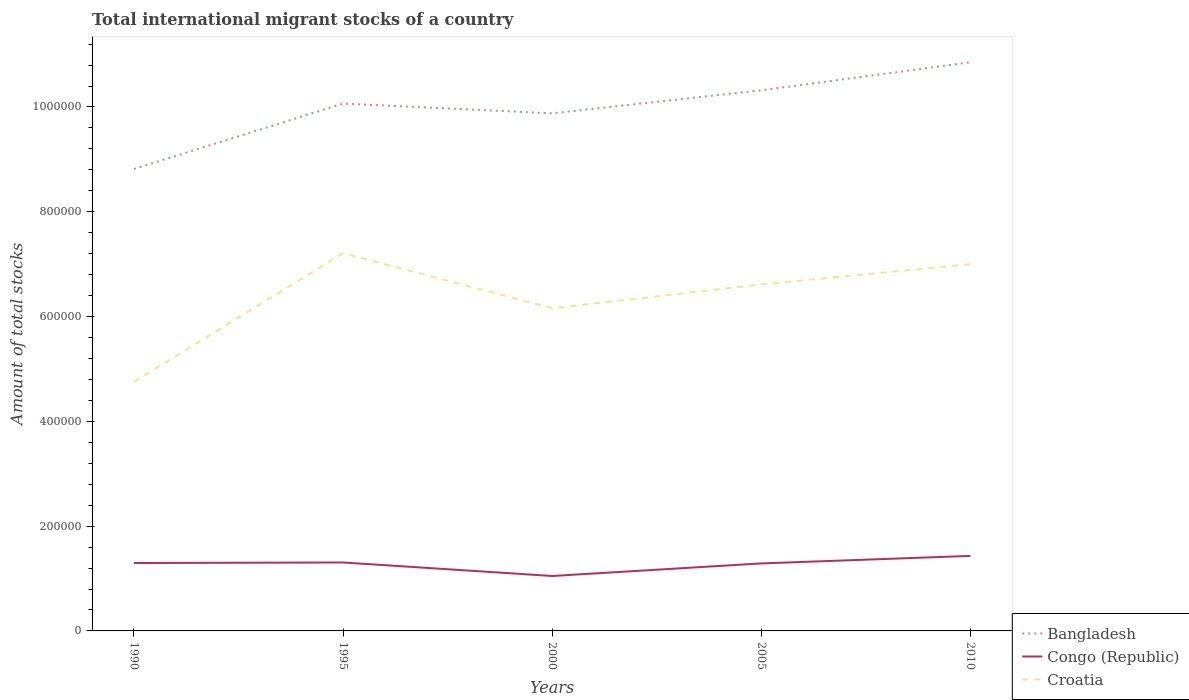How many different coloured lines are there?
Keep it short and to the point. 3. Does the line corresponding to Bangladesh intersect with the line corresponding to Croatia?
Provide a succinct answer. No. Across all years, what is the maximum amount of total stocks in in Congo (Republic)?
Give a very brief answer. 1.05e+05. What is the total amount of total stocks in in Congo (Republic) in the graph?
Your response must be concise. 2.58e+04. What is the difference between the highest and the second highest amount of total stocks in in Bangladesh?
Your answer should be very brief. 2.04e+05. What is the difference between the highest and the lowest amount of total stocks in in Congo (Republic)?
Keep it short and to the point. 4. How many years are there in the graph?
Ensure brevity in your answer.  5. Are the values on the major ticks of Y-axis written in scientific E-notation?
Your answer should be very brief. No. Does the graph contain grids?
Provide a short and direct response. No. How many legend labels are there?
Offer a terse response. 3. How are the legend labels stacked?
Provide a succinct answer. Vertical. What is the title of the graph?
Offer a terse response. Total international migrant stocks of a country. What is the label or title of the Y-axis?
Your answer should be very brief. Amount of total stocks. What is the Amount of total stocks of Bangladesh in 1990?
Give a very brief answer. 8.82e+05. What is the Amount of total stocks of Congo (Republic) in 1990?
Give a very brief answer. 1.30e+05. What is the Amount of total stocks in Croatia in 1990?
Ensure brevity in your answer.  4.75e+05. What is the Amount of total stocks in Bangladesh in 1995?
Offer a very short reply. 1.01e+06. What is the Amount of total stocks in Congo (Republic) in 1995?
Your answer should be very brief. 1.31e+05. What is the Amount of total stocks in Croatia in 1995?
Your response must be concise. 7.21e+05. What is the Amount of total stocks in Bangladesh in 2000?
Ensure brevity in your answer.  9.88e+05. What is the Amount of total stocks in Congo (Republic) in 2000?
Your response must be concise. 1.05e+05. What is the Amount of total stocks of Croatia in 2000?
Keep it short and to the point. 6.16e+05. What is the Amount of total stocks of Bangladesh in 2005?
Ensure brevity in your answer.  1.03e+06. What is the Amount of total stocks in Congo (Republic) in 2005?
Offer a terse response. 1.29e+05. What is the Amount of total stocks of Croatia in 2005?
Provide a short and direct response. 6.61e+05. What is the Amount of total stocks of Bangladesh in 2010?
Offer a very short reply. 1.09e+06. What is the Amount of total stocks in Congo (Republic) in 2010?
Make the answer very short. 1.43e+05. What is the Amount of total stocks of Croatia in 2010?
Offer a terse response. 7.00e+05. Across all years, what is the maximum Amount of total stocks of Bangladesh?
Provide a short and direct response. 1.09e+06. Across all years, what is the maximum Amount of total stocks of Congo (Republic)?
Your response must be concise. 1.43e+05. Across all years, what is the maximum Amount of total stocks in Croatia?
Offer a terse response. 7.21e+05. Across all years, what is the minimum Amount of total stocks of Bangladesh?
Make the answer very short. 8.82e+05. Across all years, what is the minimum Amount of total stocks in Congo (Republic)?
Your answer should be compact. 1.05e+05. Across all years, what is the minimum Amount of total stocks of Croatia?
Offer a terse response. 4.75e+05. What is the total Amount of total stocks in Bangladesh in the graph?
Give a very brief answer. 4.99e+06. What is the total Amount of total stocks in Congo (Republic) in the graph?
Offer a terse response. 6.37e+05. What is the total Amount of total stocks of Croatia in the graph?
Give a very brief answer. 3.17e+06. What is the difference between the Amount of total stocks in Bangladesh in 1990 and that in 1995?
Give a very brief answer. -1.25e+05. What is the difference between the Amount of total stocks of Congo (Republic) in 1990 and that in 1995?
Make the answer very short. -1040. What is the difference between the Amount of total stocks in Croatia in 1990 and that in 1995?
Keep it short and to the point. -2.46e+05. What is the difference between the Amount of total stocks in Bangladesh in 1990 and that in 2000?
Your response must be concise. -1.06e+05. What is the difference between the Amount of total stocks in Congo (Republic) in 1990 and that in 2000?
Ensure brevity in your answer.  2.47e+04. What is the difference between the Amount of total stocks in Croatia in 1990 and that in 2000?
Provide a short and direct response. -1.40e+05. What is the difference between the Amount of total stocks of Bangladesh in 1990 and that in 2005?
Provide a succinct answer. -1.50e+05. What is the difference between the Amount of total stocks in Congo (Republic) in 1990 and that in 2005?
Keep it short and to the point. 759. What is the difference between the Amount of total stocks of Croatia in 1990 and that in 2005?
Make the answer very short. -1.86e+05. What is the difference between the Amount of total stocks of Bangladesh in 1990 and that in 2010?
Your answer should be very brief. -2.04e+05. What is the difference between the Amount of total stocks in Congo (Republic) in 1990 and that in 2010?
Provide a short and direct response. -1.36e+04. What is the difference between the Amount of total stocks in Croatia in 1990 and that in 2010?
Keep it short and to the point. -2.25e+05. What is the difference between the Amount of total stocks of Bangladesh in 1995 and that in 2000?
Make the answer very short. 1.86e+04. What is the difference between the Amount of total stocks of Congo (Republic) in 1995 and that in 2000?
Provide a succinct answer. 2.58e+04. What is the difference between the Amount of total stocks of Croatia in 1995 and that in 2000?
Offer a terse response. 1.05e+05. What is the difference between the Amount of total stocks of Bangladesh in 1995 and that in 2005?
Keep it short and to the point. -2.54e+04. What is the difference between the Amount of total stocks of Congo (Republic) in 1995 and that in 2005?
Offer a very short reply. 1799. What is the difference between the Amount of total stocks of Croatia in 1995 and that in 2005?
Offer a terse response. 5.96e+04. What is the difference between the Amount of total stocks of Bangladesh in 1995 and that in 2010?
Provide a succinct answer. -7.89e+04. What is the difference between the Amount of total stocks in Congo (Republic) in 1995 and that in 2010?
Ensure brevity in your answer.  -1.26e+04. What is the difference between the Amount of total stocks in Croatia in 1995 and that in 2010?
Your answer should be very brief. 2.10e+04. What is the difference between the Amount of total stocks of Bangladesh in 2000 and that in 2005?
Provide a short and direct response. -4.40e+04. What is the difference between the Amount of total stocks in Congo (Republic) in 2000 and that in 2005?
Provide a short and direct response. -2.40e+04. What is the difference between the Amount of total stocks in Croatia in 2000 and that in 2005?
Your answer should be compact. -4.55e+04. What is the difference between the Amount of total stocks of Bangladesh in 2000 and that in 2010?
Give a very brief answer. -9.75e+04. What is the difference between the Amount of total stocks in Congo (Republic) in 2000 and that in 2010?
Make the answer very short. -3.83e+04. What is the difference between the Amount of total stocks in Croatia in 2000 and that in 2010?
Make the answer very short. -8.41e+04. What is the difference between the Amount of total stocks in Bangladesh in 2005 and that in 2010?
Give a very brief answer. -5.35e+04. What is the difference between the Amount of total stocks in Congo (Republic) in 2005 and that in 2010?
Provide a short and direct response. -1.44e+04. What is the difference between the Amount of total stocks of Croatia in 2005 and that in 2010?
Give a very brief answer. -3.86e+04. What is the difference between the Amount of total stocks in Bangladesh in 1990 and the Amount of total stocks in Congo (Republic) in 1995?
Provide a succinct answer. 7.51e+05. What is the difference between the Amount of total stocks of Bangladesh in 1990 and the Amount of total stocks of Croatia in 1995?
Offer a terse response. 1.61e+05. What is the difference between the Amount of total stocks in Congo (Republic) in 1990 and the Amount of total stocks in Croatia in 1995?
Provide a short and direct response. -5.91e+05. What is the difference between the Amount of total stocks in Bangladesh in 1990 and the Amount of total stocks in Congo (Republic) in 2000?
Offer a terse response. 7.77e+05. What is the difference between the Amount of total stocks of Bangladesh in 1990 and the Amount of total stocks of Croatia in 2000?
Provide a succinct answer. 2.66e+05. What is the difference between the Amount of total stocks of Congo (Republic) in 1990 and the Amount of total stocks of Croatia in 2000?
Provide a succinct answer. -4.86e+05. What is the difference between the Amount of total stocks of Bangladesh in 1990 and the Amount of total stocks of Congo (Republic) in 2005?
Ensure brevity in your answer.  7.53e+05. What is the difference between the Amount of total stocks in Bangladesh in 1990 and the Amount of total stocks in Croatia in 2005?
Offer a terse response. 2.20e+05. What is the difference between the Amount of total stocks in Congo (Republic) in 1990 and the Amount of total stocks in Croatia in 2005?
Give a very brief answer. -5.32e+05. What is the difference between the Amount of total stocks of Bangladesh in 1990 and the Amount of total stocks of Congo (Republic) in 2010?
Offer a very short reply. 7.38e+05. What is the difference between the Amount of total stocks of Bangladesh in 1990 and the Amount of total stocks of Croatia in 2010?
Provide a succinct answer. 1.82e+05. What is the difference between the Amount of total stocks of Congo (Republic) in 1990 and the Amount of total stocks of Croatia in 2010?
Provide a short and direct response. -5.70e+05. What is the difference between the Amount of total stocks of Bangladesh in 1995 and the Amount of total stocks of Congo (Republic) in 2000?
Provide a short and direct response. 9.02e+05. What is the difference between the Amount of total stocks of Bangladesh in 1995 and the Amount of total stocks of Croatia in 2000?
Your answer should be very brief. 3.91e+05. What is the difference between the Amount of total stocks in Congo (Republic) in 1995 and the Amount of total stocks in Croatia in 2000?
Offer a terse response. -4.85e+05. What is the difference between the Amount of total stocks of Bangladesh in 1995 and the Amount of total stocks of Congo (Republic) in 2005?
Your answer should be very brief. 8.78e+05. What is the difference between the Amount of total stocks in Bangladesh in 1995 and the Amount of total stocks in Croatia in 2005?
Provide a short and direct response. 3.45e+05. What is the difference between the Amount of total stocks of Congo (Republic) in 1995 and the Amount of total stocks of Croatia in 2005?
Your answer should be compact. -5.31e+05. What is the difference between the Amount of total stocks in Bangladesh in 1995 and the Amount of total stocks in Congo (Republic) in 2010?
Ensure brevity in your answer.  8.63e+05. What is the difference between the Amount of total stocks in Bangladesh in 1995 and the Amount of total stocks in Croatia in 2010?
Offer a terse response. 3.07e+05. What is the difference between the Amount of total stocks of Congo (Republic) in 1995 and the Amount of total stocks of Croatia in 2010?
Your response must be concise. -5.69e+05. What is the difference between the Amount of total stocks in Bangladesh in 2000 and the Amount of total stocks in Congo (Republic) in 2005?
Provide a short and direct response. 8.59e+05. What is the difference between the Amount of total stocks of Bangladesh in 2000 and the Amount of total stocks of Croatia in 2005?
Offer a very short reply. 3.26e+05. What is the difference between the Amount of total stocks in Congo (Republic) in 2000 and the Amount of total stocks in Croatia in 2005?
Keep it short and to the point. -5.57e+05. What is the difference between the Amount of total stocks of Bangladesh in 2000 and the Amount of total stocks of Congo (Republic) in 2010?
Offer a very short reply. 8.45e+05. What is the difference between the Amount of total stocks in Bangladesh in 2000 and the Amount of total stocks in Croatia in 2010?
Ensure brevity in your answer.  2.88e+05. What is the difference between the Amount of total stocks of Congo (Republic) in 2000 and the Amount of total stocks of Croatia in 2010?
Your response must be concise. -5.95e+05. What is the difference between the Amount of total stocks of Bangladesh in 2005 and the Amount of total stocks of Congo (Republic) in 2010?
Provide a short and direct response. 8.89e+05. What is the difference between the Amount of total stocks in Bangladesh in 2005 and the Amount of total stocks in Croatia in 2010?
Your answer should be compact. 3.32e+05. What is the difference between the Amount of total stocks of Congo (Republic) in 2005 and the Amount of total stocks of Croatia in 2010?
Offer a very short reply. -5.71e+05. What is the average Amount of total stocks in Bangladesh per year?
Your answer should be very brief. 9.99e+05. What is the average Amount of total stocks in Congo (Republic) per year?
Ensure brevity in your answer.  1.27e+05. What is the average Amount of total stocks in Croatia per year?
Give a very brief answer. 6.35e+05. In the year 1990, what is the difference between the Amount of total stocks in Bangladesh and Amount of total stocks in Congo (Republic)?
Give a very brief answer. 7.52e+05. In the year 1990, what is the difference between the Amount of total stocks in Bangladesh and Amount of total stocks in Croatia?
Your response must be concise. 4.06e+05. In the year 1990, what is the difference between the Amount of total stocks in Congo (Republic) and Amount of total stocks in Croatia?
Your response must be concise. -3.46e+05. In the year 1995, what is the difference between the Amount of total stocks in Bangladesh and Amount of total stocks in Congo (Republic)?
Your response must be concise. 8.76e+05. In the year 1995, what is the difference between the Amount of total stocks in Bangladesh and Amount of total stocks in Croatia?
Give a very brief answer. 2.85e+05. In the year 1995, what is the difference between the Amount of total stocks of Congo (Republic) and Amount of total stocks of Croatia?
Provide a succinct answer. -5.90e+05. In the year 2000, what is the difference between the Amount of total stocks in Bangladesh and Amount of total stocks in Congo (Republic)?
Keep it short and to the point. 8.83e+05. In the year 2000, what is the difference between the Amount of total stocks of Bangladesh and Amount of total stocks of Croatia?
Provide a short and direct response. 3.72e+05. In the year 2000, what is the difference between the Amount of total stocks in Congo (Republic) and Amount of total stocks in Croatia?
Your answer should be compact. -5.11e+05. In the year 2005, what is the difference between the Amount of total stocks in Bangladesh and Amount of total stocks in Congo (Republic)?
Make the answer very short. 9.03e+05. In the year 2005, what is the difference between the Amount of total stocks in Bangladesh and Amount of total stocks in Croatia?
Provide a short and direct response. 3.71e+05. In the year 2005, what is the difference between the Amount of total stocks of Congo (Republic) and Amount of total stocks of Croatia?
Provide a short and direct response. -5.33e+05. In the year 2010, what is the difference between the Amount of total stocks of Bangladesh and Amount of total stocks of Congo (Republic)?
Provide a short and direct response. 9.42e+05. In the year 2010, what is the difference between the Amount of total stocks in Bangladesh and Amount of total stocks in Croatia?
Provide a succinct answer. 3.85e+05. In the year 2010, what is the difference between the Amount of total stocks in Congo (Republic) and Amount of total stocks in Croatia?
Make the answer very short. -5.57e+05. What is the ratio of the Amount of total stocks in Bangladesh in 1990 to that in 1995?
Keep it short and to the point. 0.88. What is the ratio of the Amount of total stocks of Congo (Republic) in 1990 to that in 1995?
Your answer should be compact. 0.99. What is the ratio of the Amount of total stocks in Croatia in 1990 to that in 1995?
Ensure brevity in your answer.  0.66. What is the ratio of the Amount of total stocks of Bangladesh in 1990 to that in 2000?
Provide a short and direct response. 0.89. What is the ratio of the Amount of total stocks in Congo (Republic) in 1990 to that in 2000?
Provide a succinct answer. 1.24. What is the ratio of the Amount of total stocks of Croatia in 1990 to that in 2000?
Give a very brief answer. 0.77. What is the ratio of the Amount of total stocks in Bangladesh in 1990 to that in 2005?
Ensure brevity in your answer.  0.85. What is the ratio of the Amount of total stocks of Congo (Republic) in 1990 to that in 2005?
Keep it short and to the point. 1.01. What is the ratio of the Amount of total stocks of Croatia in 1990 to that in 2005?
Your answer should be very brief. 0.72. What is the ratio of the Amount of total stocks in Bangladesh in 1990 to that in 2010?
Give a very brief answer. 0.81. What is the ratio of the Amount of total stocks of Congo (Republic) in 1990 to that in 2010?
Your response must be concise. 0.91. What is the ratio of the Amount of total stocks in Croatia in 1990 to that in 2010?
Your answer should be very brief. 0.68. What is the ratio of the Amount of total stocks of Bangladesh in 1995 to that in 2000?
Provide a short and direct response. 1.02. What is the ratio of the Amount of total stocks of Congo (Republic) in 1995 to that in 2000?
Give a very brief answer. 1.25. What is the ratio of the Amount of total stocks of Croatia in 1995 to that in 2000?
Make the answer very short. 1.17. What is the ratio of the Amount of total stocks of Bangladesh in 1995 to that in 2005?
Offer a very short reply. 0.98. What is the ratio of the Amount of total stocks of Croatia in 1995 to that in 2005?
Keep it short and to the point. 1.09. What is the ratio of the Amount of total stocks of Bangladesh in 1995 to that in 2010?
Provide a short and direct response. 0.93. What is the ratio of the Amount of total stocks of Congo (Republic) in 1995 to that in 2010?
Keep it short and to the point. 0.91. What is the ratio of the Amount of total stocks in Bangladesh in 2000 to that in 2005?
Your answer should be very brief. 0.96. What is the ratio of the Amount of total stocks in Congo (Republic) in 2000 to that in 2005?
Your answer should be very brief. 0.81. What is the ratio of the Amount of total stocks of Croatia in 2000 to that in 2005?
Provide a short and direct response. 0.93. What is the ratio of the Amount of total stocks in Bangladesh in 2000 to that in 2010?
Ensure brevity in your answer.  0.91. What is the ratio of the Amount of total stocks of Congo (Republic) in 2000 to that in 2010?
Offer a terse response. 0.73. What is the ratio of the Amount of total stocks of Croatia in 2000 to that in 2010?
Give a very brief answer. 0.88. What is the ratio of the Amount of total stocks of Bangladesh in 2005 to that in 2010?
Provide a succinct answer. 0.95. What is the ratio of the Amount of total stocks in Congo (Republic) in 2005 to that in 2010?
Your response must be concise. 0.9. What is the ratio of the Amount of total stocks in Croatia in 2005 to that in 2010?
Ensure brevity in your answer.  0.94. What is the difference between the highest and the second highest Amount of total stocks in Bangladesh?
Keep it short and to the point. 5.35e+04. What is the difference between the highest and the second highest Amount of total stocks of Congo (Republic)?
Your answer should be compact. 1.26e+04. What is the difference between the highest and the second highest Amount of total stocks of Croatia?
Offer a terse response. 2.10e+04. What is the difference between the highest and the lowest Amount of total stocks in Bangladesh?
Offer a very short reply. 2.04e+05. What is the difference between the highest and the lowest Amount of total stocks in Congo (Republic)?
Provide a short and direct response. 3.83e+04. What is the difference between the highest and the lowest Amount of total stocks in Croatia?
Offer a very short reply. 2.46e+05. 